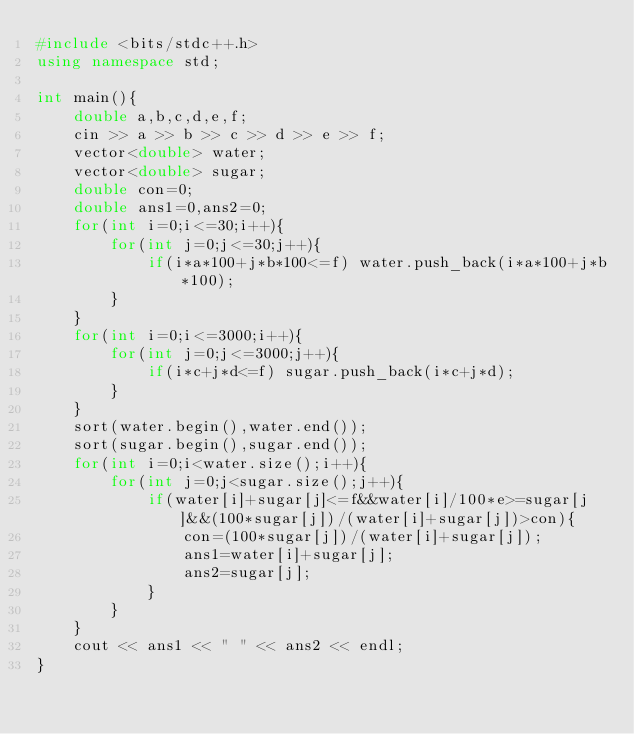Convert code to text. <code><loc_0><loc_0><loc_500><loc_500><_C++_>#include <bits/stdc++.h>
using namespace std;

int main(){
    double a,b,c,d,e,f;
    cin >> a >> b >> c >> d >> e >> f;
    vector<double> water;
    vector<double> sugar;
    double con=0;
    double ans1=0,ans2=0;
    for(int i=0;i<=30;i++){
        for(int j=0;j<=30;j++){
            if(i*a*100+j*b*100<=f) water.push_back(i*a*100+j*b*100);
        }
    }
    for(int i=0;i<=3000;i++){
        for(int j=0;j<=3000;j++){
            if(i*c+j*d<=f) sugar.push_back(i*c+j*d);
        }
    }
    sort(water.begin(),water.end());
    sort(sugar.begin(),sugar.end());
    for(int i=0;i<water.size();i++){
        for(int j=0;j<sugar.size();j++){
            if(water[i]+sugar[j]<=f&&water[i]/100*e>=sugar[j]&&(100*sugar[j])/(water[i]+sugar[j])>con){
                con=(100*sugar[j])/(water[i]+sugar[j]);
                ans1=water[i]+sugar[j];
                ans2=sugar[j];
            }
        }
    }
    cout << ans1 << " " << ans2 << endl;
}</code> 